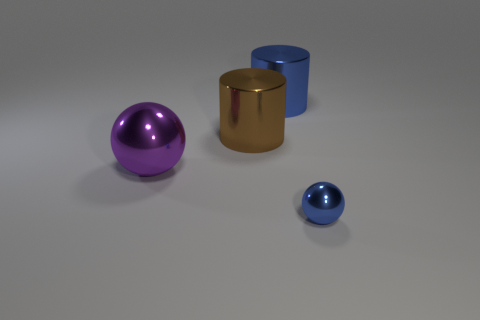Add 4 tiny objects. How many objects exist? 8 Subtract all yellow spheres. How many red cylinders are left? 0 Subtract 0 cyan balls. How many objects are left? 4 Subtract all brown spheres. Subtract all gray cylinders. How many spheres are left? 2 Subtract all tiny brown metal objects. Subtract all big purple shiny spheres. How many objects are left? 3 Add 1 big objects. How many big objects are left? 4 Add 2 large blue metal cylinders. How many large blue metal cylinders exist? 3 